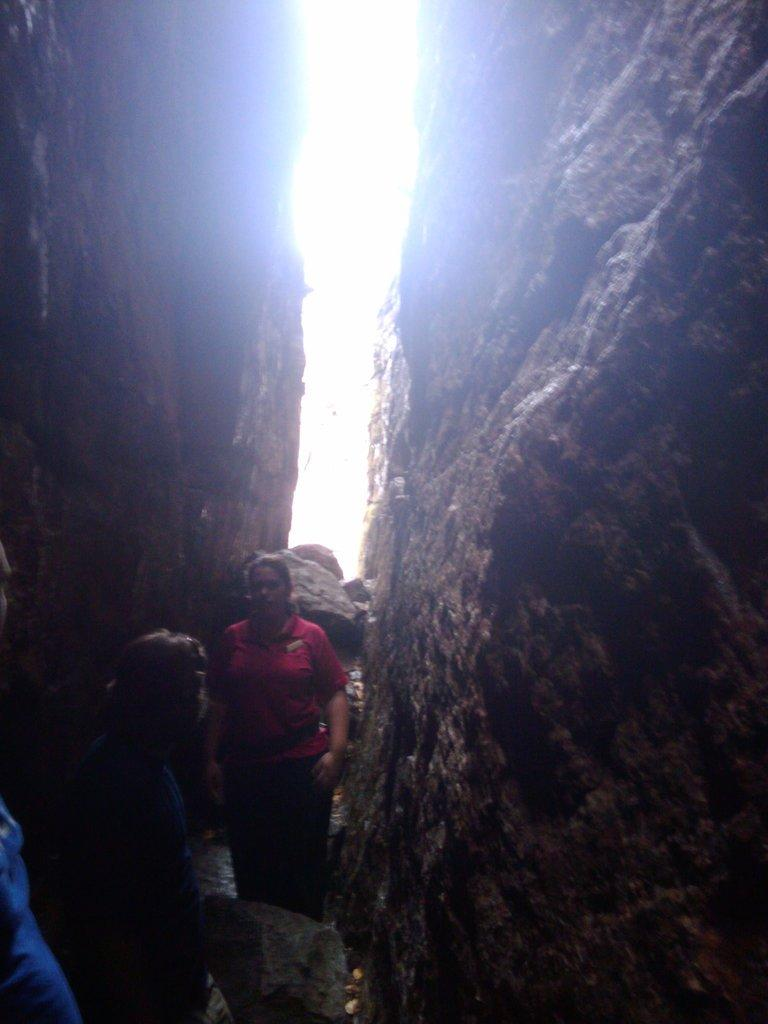How many people are in the image? There are three people standing in the image. What else can be seen in the image besides the people? There are rocks in the image. What is visible at the top of the image? The sky is visible at the top of the image. What type of care is being provided to the rocks in the image? There is no indication in the image that the rocks are receiving any care. 